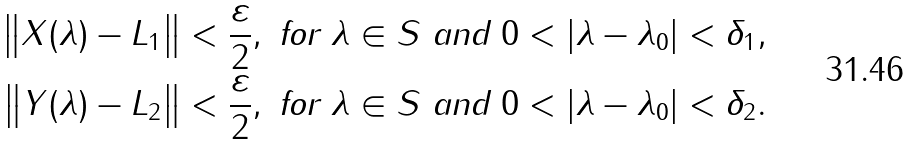Convert formula to latex. <formula><loc_0><loc_0><loc_500><loc_500>\left \| X ( \lambda ) - L _ { 1 } \right \| & < \frac { \varepsilon } { 2 } , \text { for } \lambda \in S \text { and } 0 < \left | \lambda - \lambda _ { 0 } \right | < \delta _ { 1 } , \\ \left \| Y ( \lambda ) - L _ { 2 } \right \| & < \frac { \varepsilon } { 2 } , \text { for } \lambda \in S \text { and } 0 < \left | \lambda - \lambda _ { 0 } \right | < \delta _ { 2 } .</formula> 